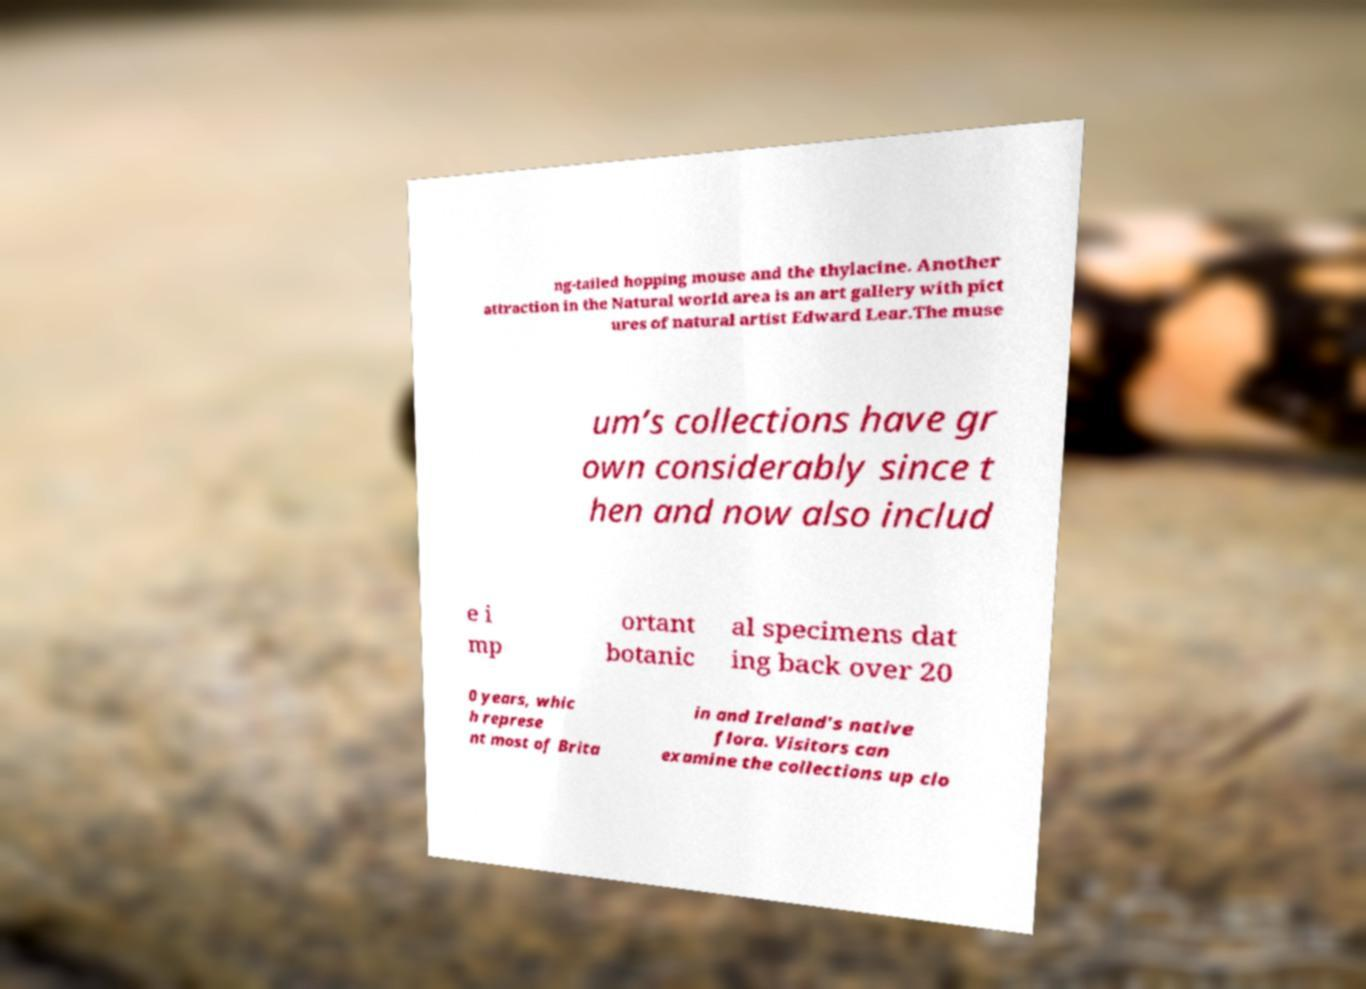For documentation purposes, I need the text within this image transcribed. Could you provide that? ng-tailed hopping mouse and the thylacine. Another attraction in the Natural world area is an art gallery with pict ures of natural artist Edward Lear.The muse um’s collections have gr own considerably since t hen and now also includ e i mp ortant botanic al specimens dat ing back over 20 0 years, whic h represe nt most of Brita in and Ireland’s native flora. Visitors can examine the collections up clo 